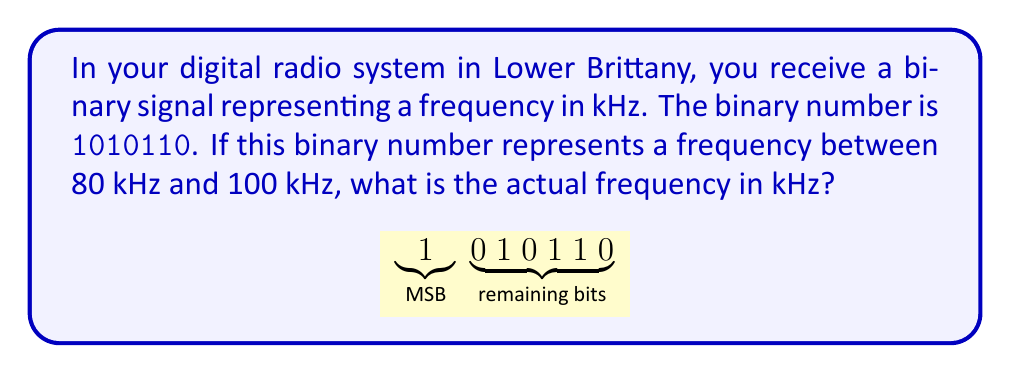What is the answer to this math problem? Let's approach this step-by-step:

1) First, we need to convert the binary number 1010110 to decimal.
   
   $$1010110_2 = 1\cdot2^6 + 0\cdot2^5 + 1\cdot2^4 + 0\cdot2^3 + 1\cdot2^2 + 1\cdot2^1 + 0\cdot2^0$$
   
   $$= 64 + 0 + 16 + 0 + 4 + 2 + 0 = 86_{10}$$

2) Now we know that 1010110 in binary is equal to 86 in decimal.

3) Given that this number represents a frequency between 80 kHz and 100 kHz, we can conclude that 86 directly corresponds to 86 kHz.

4) Therefore, the actual frequency represented by the binary number 1010110 is 86 kHz.

This system likely uses a simple encoding where the binary number directly represents the frequency in kHz, which is an efficient method for digital radio systems operating within a specific frequency range.
Answer: 86 kHz 